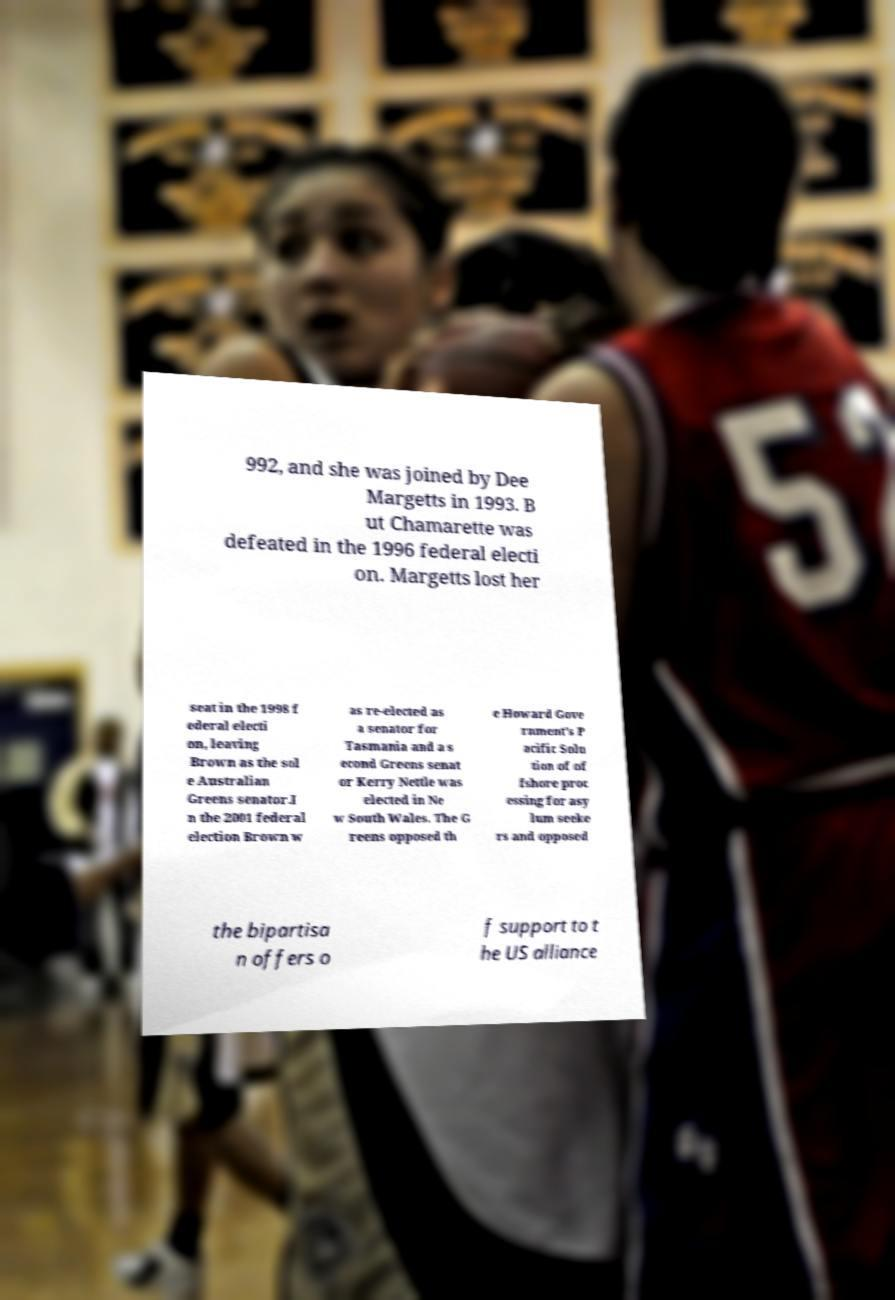I need the written content from this picture converted into text. Can you do that? 992, and she was joined by Dee Margetts in 1993. B ut Chamarette was defeated in the 1996 federal electi on. Margetts lost her seat in the 1998 f ederal electi on, leaving Brown as the sol e Australian Greens senator.I n the 2001 federal election Brown w as re-elected as a senator for Tasmania and a s econd Greens senat or Kerry Nettle was elected in Ne w South Wales. The G reens opposed th e Howard Gove rnment's P acific Solu tion of of fshore proc essing for asy lum seeke rs and opposed the bipartisa n offers o f support to t he US alliance 